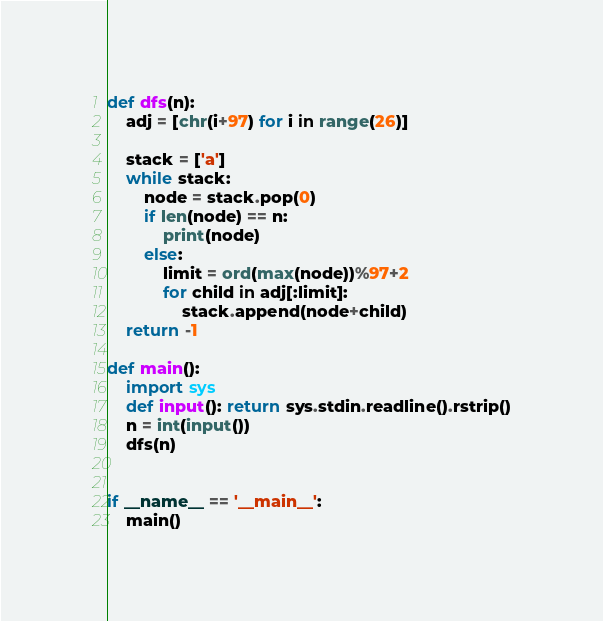Convert code to text. <code><loc_0><loc_0><loc_500><loc_500><_Python_>def dfs(n):
    adj = [chr(i+97) for i in range(26)]
    
    stack = ['a']
    while stack:
        node = stack.pop(0)
        if len(node) == n:
            print(node)
        else:
            limit = ord(max(node))%97+2
            for child in adj[:limit]:
                stack.append(node+child)
    return -1

def main():
    import sys
    def input(): return sys.stdin.readline().rstrip()
    n = int(input())
    dfs(n)


if __name__ == '__main__':
    main()</code> 